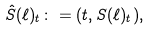<formula> <loc_0><loc_0><loc_500><loc_500>\hat { S } ( \ell ) _ { t } \colon = ( t , S ( \ell ) _ { t } ) ,</formula> 